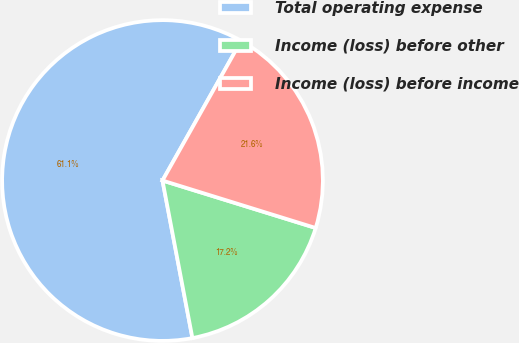Convert chart. <chart><loc_0><loc_0><loc_500><loc_500><pie_chart><fcel>Total operating expense<fcel>Income (loss) before other<fcel>Income (loss) before income<nl><fcel>61.15%<fcel>17.23%<fcel>21.62%<nl></chart> 